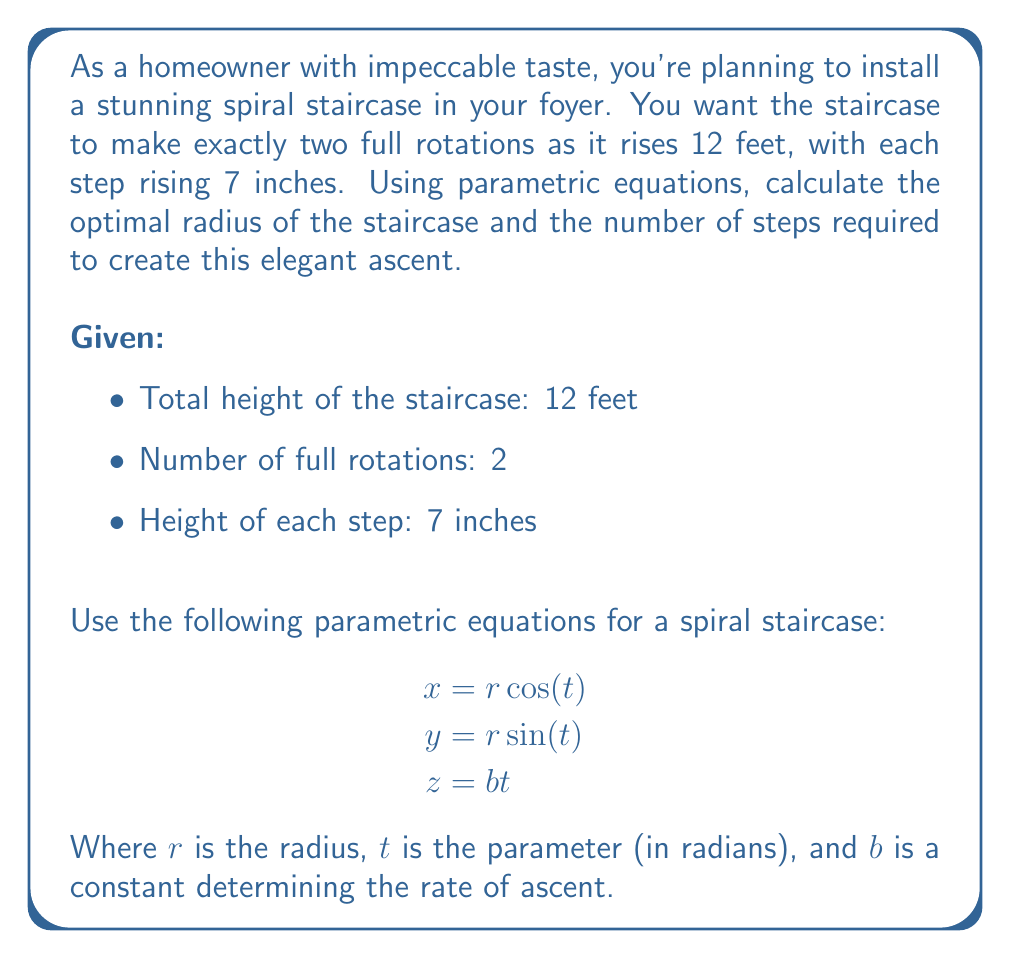Could you help me with this problem? Let's approach this problem step by step:

1) First, we need to determine the value of $b$ in the equation $z = bt$. We know that when the staircase completes two full rotations, it should reach a height of 12 feet.

   Two full rotations correspond to $t = 4\pi$ radians.
   $$12 = b(4\pi)$$
   $$b = \frac{12}{4\pi} = \frac{3}{\pi} \text{ feet/radian}$$

2) Now, let's calculate the number of steps. We know each step rises 7 inches, and the total height is 12 feet.

   Number of steps = $\frac{12 \text{ feet} \times 12 \text{ inches/foot}}{7 \text{ inches/step}} = \frac{144}{7} \approx 20.57$

   Rounding to the nearest whole number, we need 21 steps.

3) To find the radius, we need to consider the arc length of the spiral. The arc length for one complete revolution is $2\pi r$, where $r$ is the radius.

   For two complete revolutions with 21 steps, each step should cover an arc length of:
   $$\text{Arc length per step} = \frac{4\pi r}{21}$$

4) A comfortable step width is typically around 25 inches (2.08 feet). Setting this equal to our arc length per step:

   $$2.08 = \frac{4\pi r}{21}$$
   $$r = \frac{2.08 \times 21}{4\pi} \approx 3.47 \text{ feet}$$

5) To verify, let's check if this radius allows for a comfortable tread depth. The tread depth at the midpoint of the step should be at least 9 inches for safety.

   Tread depth = $\sqrt{(\text{Arc length per step})^2 - (\text{Step height})^2}$
                = $\sqrt{(2.08)^2 - (\frac{7}{12})^2} \approx 1.97 \text{ feet} = 23.64 \text{ inches}$

   This is indeed greater than 9 inches, confirming our calculation.
Answer: The optimal radius for the spiral staircase is approximately 3.47 feet, and it should have 21 steps. 